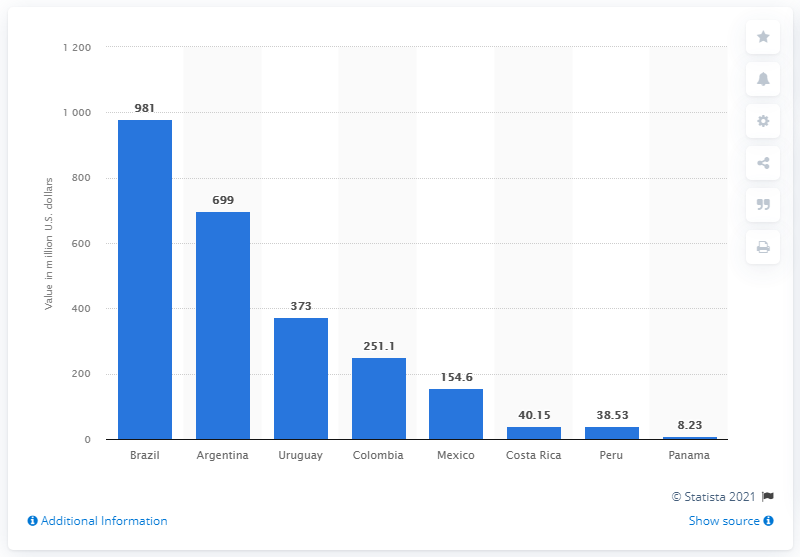Draw attention to some important aspects in this diagram. The market value of the Brazilian soccer team was 981. Argentina's market value was approximately 699... 